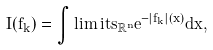Convert formula to latex. <formula><loc_0><loc_0><loc_500><loc_500>I ( f _ { k } ) = \int \lim i t s _ { \mathbb { R } ^ { n } } e ^ { - | f _ { k } | ( x ) } d x ,</formula> 